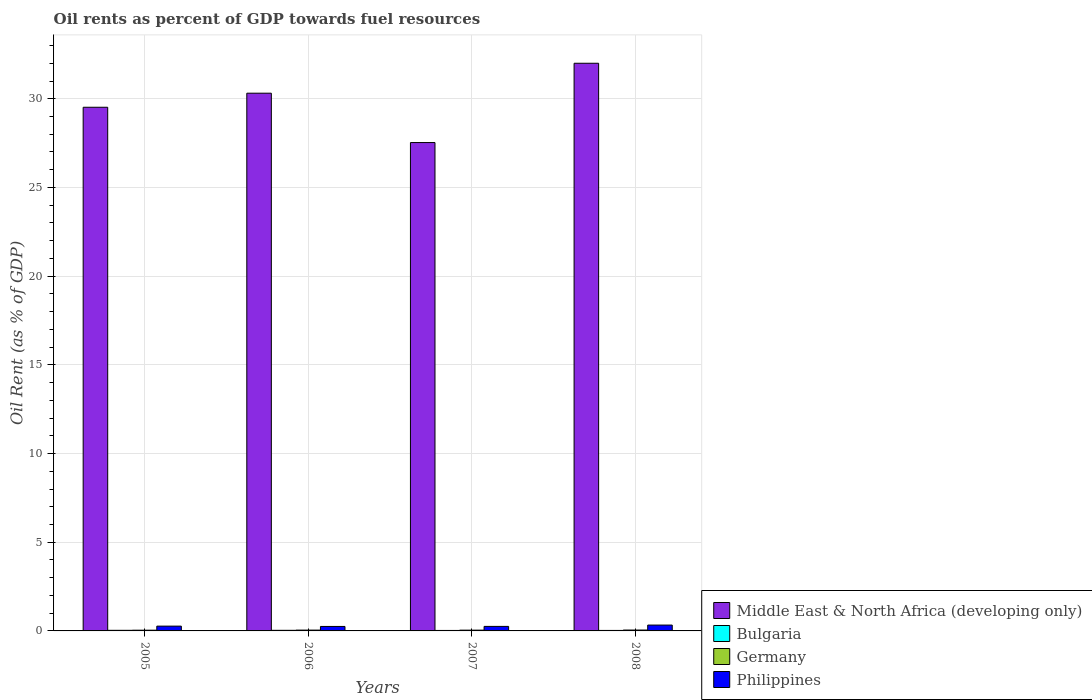How many different coloured bars are there?
Your response must be concise. 4. How many groups of bars are there?
Ensure brevity in your answer.  4. What is the oil rent in Middle East & North Africa (developing only) in 2007?
Make the answer very short. 27.53. Across all years, what is the maximum oil rent in Middle East & North Africa (developing only)?
Ensure brevity in your answer.  32. Across all years, what is the minimum oil rent in Philippines?
Give a very brief answer. 0.25. In which year was the oil rent in Middle East & North Africa (developing only) minimum?
Your answer should be compact. 2007. What is the total oil rent in Middle East & North Africa (developing only) in the graph?
Offer a terse response. 119.37. What is the difference between the oil rent in Germany in 2006 and that in 2008?
Offer a terse response. -0. What is the difference between the oil rent in Bulgaria in 2007 and the oil rent in Philippines in 2005?
Make the answer very short. -0.24. What is the average oil rent in Middle East & North Africa (developing only) per year?
Your answer should be compact. 29.84. In the year 2006, what is the difference between the oil rent in Middle East & North Africa (developing only) and oil rent in Philippines?
Your answer should be very brief. 30.06. In how many years, is the oil rent in Philippines greater than 4 %?
Offer a terse response. 0. What is the ratio of the oil rent in Philippines in 2006 to that in 2007?
Make the answer very short. 0.99. Is the difference between the oil rent in Middle East & North Africa (developing only) in 2007 and 2008 greater than the difference between the oil rent in Philippines in 2007 and 2008?
Your response must be concise. No. What is the difference between the highest and the second highest oil rent in Middle East & North Africa (developing only)?
Ensure brevity in your answer.  1.69. What is the difference between the highest and the lowest oil rent in Bulgaria?
Offer a terse response. 0.01. In how many years, is the oil rent in Philippines greater than the average oil rent in Philippines taken over all years?
Offer a very short reply. 1. Is it the case that in every year, the sum of the oil rent in Middle East & North Africa (developing only) and oil rent in Germany is greater than the sum of oil rent in Bulgaria and oil rent in Philippines?
Give a very brief answer. Yes. What does the 3rd bar from the left in 2007 represents?
Provide a succinct answer. Germany. What does the 4th bar from the right in 2006 represents?
Your answer should be very brief. Middle East & North Africa (developing only). Is it the case that in every year, the sum of the oil rent in Middle East & North Africa (developing only) and oil rent in Bulgaria is greater than the oil rent in Germany?
Offer a terse response. Yes. Are all the bars in the graph horizontal?
Provide a succinct answer. No. Does the graph contain grids?
Your response must be concise. Yes. What is the title of the graph?
Provide a succinct answer. Oil rents as percent of GDP towards fuel resources. What is the label or title of the Y-axis?
Ensure brevity in your answer.  Oil Rent (as % of GDP). What is the Oil Rent (as % of GDP) in Middle East & North Africa (developing only) in 2005?
Provide a short and direct response. 29.52. What is the Oil Rent (as % of GDP) of Bulgaria in 2005?
Offer a terse response. 0.03. What is the Oil Rent (as % of GDP) of Germany in 2005?
Offer a very short reply. 0.04. What is the Oil Rent (as % of GDP) in Philippines in 2005?
Your answer should be very brief. 0.27. What is the Oil Rent (as % of GDP) of Middle East & North Africa (developing only) in 2006?
Your answer should be very brief. 30.31. What is the Oil Rent (as % of GDP) of Bulgaria in 2006?
Give a very brief answer. 0.03. What is the Oil Rent (as % of GDP) of Germany in 2006?
Your answer should be compact. 0.05. What is the Oil Rent (as % of GDP) in Philippines in 2006?
Ensure brevity in your answer.  0.25. What is the Oil Rent (as % of GDP) of Middle East & North Africa (developing only) in 2007?
Ensure brevity in your answer.  27.53. What is the Oil Rent (as % of GDP) of Bulgaria in 2007?
Make the answer very short. 0.03. What is the Oil Rent (as % of GDP) of Germany in 2007?
Your answer should be compact. 0.04. What is the Oil Rent (as % of GDP) in Philippines in 2007?
Make the answer very short. 0.25. What is the Oil Rent (as % of GDP) in Middle East & North Africa (developing only) in 2008?
Provide a succinct answer. 32. What is the Oil Rent (as % of GDP) of Bulgaria in 2008?
Give a very brief answer. 0.03. What is the Oil Rent (as % of GDP) of Germany in 2008?
Offer a very short reply. 0.05. What is the Oil Rent (as % of GDP) of Philippines in 2008?
Ensure brevity in your answer.  0.33. Across all years, what is the maximum Oil Rent (as % of GDP) of Middle East & North Africa (developing only)?
Give a very brief answer. 32. Across all years, what is the maximum Oil Rent (as % of GDP) in Bulgaria?
Offer a very short reply. 0.03. Across all years, what is the maximum Oil Rent (as % of GDP) in Germany?
Your answer should be very brief. 0.05. Across all years, what is the maximum Oil Rent (as % of GDP) in Philippines?
Provide a succinct answer. 0.33. Across all years, what is the minimum Oil Rent (as % of GDP) in Middle East & North Africa (developing only)?
Offer a very short reply. 27.53. Across all years, what is the minimum Oil Rent (as % of GDP) in Bulgaria?
Ensure brevity in your answer.  0.03. Across all years, what is the minimum Oil Rent (as % of GDP) in Germany?
Offer a very short reply. 0.04. Across all years, what is the minimum Oil Rent (as % of GDP) of Philippines?
Provide a short and direct response. 0.25. What is the total Oil Rent (as % of GDP) in Middle East & North Africa (developing only) in the graph?
Ensure brevity in your answer.  119.37. What is the total Oil Rent (as % of GDP) in Bulgaria in the graph?
Your answer should be compact. 0.12. What is the total Oil Rent (as % of GDP) of Germany in the graph?
Provide a short and direct response. 0.18. What is the total Oil Rent (as % of GDP) of Philippines in the graph?
Give a very brief answer. 1.11. What is the difference between the Oil Rent (as % of GDP) in Middle East & North Africa (developing only) in 2005 and that in 2006?
Ensure brevity in your answer.  -0.79. What is the difference between the Oil Rent (as % of GDP) in Germany in 2005 and that in 2006?
Provide a short and direct response. -0.01. What is the difference between the Oil Rent (as % of GDP) of Philippines in 2005 and that in 2006?
Ensure brevity in your answer.  0.02. What is the difference between the Oil Rent (as % of GDP) in Middle East & North Africa (developing only) in 2005 and that in 2007?
Give a very brief answer. 1.99. What is the difference between the Oil Rent (as % of GDP) in Bulgaria in 2005 and that in 2007?
Offer a very short reply. 0.01. What is the difference between the Oil Rent (as % of GDP) in Germany in 2005 and that in 2007?
Give a very brief answer. -0. What is the difference between the Oil Rent (as % of GDP) of Philippines in 2005 and that in 2007?
Your answer should be compact. 0.02. What is the difference between the Oil Rent (as % of GDP) in Middle East & North Africa (developing only) in 2005 and that in 2008?
Provide a succinct answer. -2.48. What is the difference between the Oil Rent (as % of GDP) in Bulgaria in 2005 and that in 2008?
Provide a short and direct response. 0.01. What is the difference between the Oil Rent (as % of GDP) in Germany in 2005 and that in 2008?
Ensure brevity in your answer.  -0.01. What is the difference between the Oil Rent (as % of GDP) in Philippines in 2005 and that in 2008?
Your response must be concise. -0.06. What is the difference between the Oil Rent (as % of GDP) in Middle East & North Africa (developing only) in 2006 and that in 2007?
Provide a succinct answer. 2.78. What is the difference between the Oil Rent (as % of GDP) in Bulgaria in 2006 and that in 2007?
Keep it short and to the point. 0.01. What is the difference between the Oil Rent (as % of GDP) of Germany in 2006 and that in 2007?
Your answer should be very brief. 0. What is the difference between the Oil Rent (as % of GDP) in Philippines in 2006 and that in 2007?
Offer a very short reply. -0. What is the difference between the Oil Rent (as % of GDP) of Middle East & North Africa (developing only) in 2006 and that in 2008?
Offer a very short reply. -1.69. What is the difference between the Oil Rent (as % of GDP) of Bulgaria in 2006 and that in 2008?
Your answer should be very brief. 0.01. What is the difference between the Oil Rent (as % of GDP) in Germany in 2006 and that in 2008?
Offer a very short reply. -0. What is the difference between the Oil Rent (as % of GDP) of Philippines in 2006 and that in 2008?
Make the answer very short. -0.08. What is the difference between the Oil Rent (as % of GDP) of Middle East & North Africa (developing only) in 2007 and that in 2008?
Ensure brevity in your answer.  -4.47. What is the difference between the Oil Rent (as % of GDP) of Bulgaria in 2007 and that in 2008?
Provide a short and direct response. -0. What is the difference between the Oil Rent (as % of GDP) of Germany in 2007 and that in 2008?
Your answer should be very brief. -0.01. What is the difference between the Oil Rent (as % of GDP) in Philippines in 2007 and that in 2008?
Your response must be concise. -0.07. What is the difference between the Oil Rent (as % of GDP) of Middle East & North Africa (developing only) in 2005 and the Oil Rent (as % of GDP) of Bulgaria in 2006?
Ensure brevity in your answer.  29.49. What is the difference between the Oil Rent (as % of GDP) in Middle East & North Africa (developing only) in 2005 and the Oil Rent (as % of GDP) in Germany in 2006?
Ensure brevity in your answer.  29.47. What is the difference between the Oil Rent (as % of GDP) in Middle East & North Africa (developing only) in 2005 and the Oil Rent (as % of GDP) in Philippines in 2006?
Keep it short and to the point. 29.27. What is the difference between the Oil Rent (as % of GDP) in Bulgaria in 2005 and the Oil Rent (as % of GDP) in Germany in 2006?
Provide a succinct answer. -0.01. What is the difference between the Oil Rent (as % of GDP) of Bulgaria in 2005 and the Oil Rent (as % of GDP) of Philippines in 2006?
Your answer should be compact. -0.22. What is the difference between the Oil Rent (as % of GDP) of Germany in 2005 and the Oil Rent (as % of GDP) of Philippines in 2006?
Your response must be concise. -0.21. What is the difference between the Oil Rent (as % of GDP) in Middle East & North Africa (developing only) in 2005 and the Oil Rent (as % of GDP) in Bulgaria in 2007?
Your answer should be compact. 29.49. What is the difference between the Oil Rent (as % of GDP) in Middle East & North Africa (developing only) in 2005 and the Oil Rent (as % of GDP) in Germany in 2007?
Offer a terse response. 29.48. What is the difference between the Oil Rent (as % of GDP) in Middle East & North Africa (developing only) in 2005 and the Oil Rent (as % of GDP) in Philippines in 2007?
Give a very brief answer. 29.27. What is the difference between the Oil Rent (as % of GDP) of Bulgaria in 2005 and the Oil Rent (as % of GDP) of Germany in 2007?
Keep it short and to the point. -0.01. What is the difference between the Oil Rent (as % of GDP) in Bulgaria in 2005 and the Oil Rent (as % of GDP) in Philippines in 2007?
Your response must be concise. -0.22. What is the difference between the Oil Rent (as % of GDP) in Germany in 2005 and the Oil Rent (as % of GDP) in Philippines in 2007?
Provide a short and direct response. -0.21. What is the difference between the Oil Rent (as % of GDP) in Middle East & North Africa (developing only) in 2005 and the Oil Rent (as % of GDP) in Bulgaria in 2008?
Your answer should be compact. 29.49. What is the difference between the Oil Rent (as % of GDP) of Middle East & North Africa (developing only) in 2005 and the Oil Rent (as % of GDP) of Germany in 2008?
Give a very brief answer. 29.47. What is the difference between the Oil Rent (as % of GDP) of Middle East & North Africa (developing only) in 2005 and the Oil Rent (as % of GDP) of Philippines in 2008?
Provide a succinct answer. 29.19. What is the difference between the Oil Rent (as % of GDP) of Bulgaria in 2005 and the Oil Rent (as % of GDP) of Germany in 2008?
Give a very brief answer. -0.02. What is the difference between the Oil Rent (as % of GDP) in Bulgaria in 2005 and the Oil Rent (as % of GDP) in Philippines in 2008?
Your answer should be very brief. -0.3. What is the difference between the Oil Rent (as % of GDP) of Germany in 2005 and the Oil Rent (as % of GDP) of Philippines in 2008?
Offer a terse response. -0.29. What is the difference between the Oil Rent (as % of GDP) of Middle East & North Africa (developing only) in 2006 and the Oil Rent (as % of GDP) of Bulgaria in 2007?
Give a very brief answer. 30.29. What is the difference between the Oil Rent (as % of GDP) in Middle East & North Africa (developing only) in 2006 and the Oil Rent (as % of GDP) in Germany in 2007?
Give a very brief answer. 30.27. What is the difference between the Oil Rent (as % of GDP) of Middle East & North Africa (developing only) in 2006 and the Oil Rent (as % of GDP) of Philippines in 2007?
Ensure brevity in your answer.  30.06. What is the difference between the Oil Rent (as % of GDP) in Bulgaria in 2006 and the Oil Rent (as % of GDP) in Germany in 2007?
Ensure brevity in your answer.  -0.01. What is the difference between the Oil Rent (as % of GDP) in Bulgaria in 2006 and the Oil Rent (as % of GDP) in Philippines in 2007?
Offer a very short reply. -0.22. What is the difference between the Oil Rent (as % of GDP) of Germany in 2006 and the Oil Rent (as % of GDP) of Philippines in 2007?
Make the answer very short. -0.21. What is the difference between the Oil Rent (as % of GDP) in Middle East & North Africa (developing only) in 2006 and the Oil Rent (as % of GDP) in Bulgaria in 2008?
Your answer should be very brief. 30.29. What is the difference between the Oil Rent (as % of GDP) of Middle East & North Africa (developing only) in 2006 and the Oil Rent (as % of GDP) of Germany in 2008?
Make the answer very short. 30.26. What is the difference between the Oil Rent (as % of GDP) of Middle East & North Africa (developing only) in 2006 and the Oil Rent (as % of GDP) of Philippines in 2008?
Offer a terse response. 29.98. What is the difference between the Oil Rent (as % of GDP) in Bulgaria in 2006 and the Oil Rent (as % of GDP) in Germany in 2008?
Ensure brevity in your answer.  -0.02. What is the difference between the Oil Rent (as % of GDP) in Bulgaria in 2006 and the Oil Rent (as % of GDP) in Philippines in 2008?
Ensure brevity in your answer.  -0.3. What is the difference between the Oil Rent (as % of GDP) in Germany in 2006 and the Oil Rent (as % of GDP) in Philippines in 2008?
Offer a very short reply. -0.28. What is the difference between the Oil Rent (as % of GDP) in Middle East & North Africa (developing only) in 2007 and the Oil Rent (as % of GDP) in Bulgaria in 2008?
Offer a very short reply. 27.5. What is the difference between the Oil Rent (as % of GDP) of Middle East & North Africa (developing only) in 2007 and the Oil Rent (as % of GDP) of Germany in 2008?
Your response must be concise. 27.48. What is the difference between the Oil Rent (as % of GDP) of Middle East & North Africa (developing only) in 2007 and the Oil Rent (as % of GDP) of Philippines in 2008?
Make the answer very short. 27.2. What is the difference between the Oil Rent (as % of GDP) of Bulgaria in 2007 and the Oil Rent (as % of GDP) of Germany in 2008?
Make the answer very short. -0.02. What is the difference between the Oil Rent (as % of GDP) in Bulgaria in 2007 and the Oil Rent (as % of GDP) in Philippines in 2008?
Your answer should be compact. -0.3. What is the difference between the Oil Rent (as % of GDP) in Germany in 2007 and the Oil Rent (as % of GDP) in Philippines in 2008?
Offer a terse response. -0.29. What is the average Oil Rent (as % of GDP) of Middle East & North Africa (developing only) per year?
Give a very brief answer. 29.84. What is the average Oil Rent (as % of GDP) of Bulgaria per year?
Provide a succinct answer. 0.03. What is the average Oil Rent (as % of GDP) in Germany per year?
Your response must be concise. 0.05. What is the average Oil Rent (as % of GDP) in Philippines per year?
Your response must be concise. 0.28. In the year 2005, what is the difference between the Oil Rent (as % of GDP) of Middle East & North Africa (developing only) and Oil Rent (as % of GDP) of Bulgaria?
Your response must be concise. 29.49. In the year 2005, what is the difference between the Oil Rent (as % of GDP) of Middle East & North Africa (developing only) and Oil Rent (as % of GDP) of Germany?
Your answer should be very brief. 29.48. In the year 2005, what is the difference between the Oil Rent (as % of GDP) of Middle East & North Africa (developing only) and Oil Rent (as % of GDP) of Philippines?
Give a very brief answer. 29.25. In the year 2005, what is the difference between the Oil Rent (as % of GDP) of Bulgaria and Oil Rent (as % of GDP) of Germany?
Your response must be concise. -0.01. In the year 2005, what is the difference between the Oil Rent (as % of GDP) of Bulgaria and Oil Rent (as % of GDP) of Philippines?
Provide a succinct answer. -0.24. In the year 2005, what is the difference between the Oil Rent (as % of GDP) of Germany and Oil Rent (as % of GDP) of Philippines?
Offer a terse response. -0.23. In the year 2006, what is the difference between the Oil Rent (as % of GDP) of Middle East & North Africa (developing only) and Oil Rent (as % of GDP) of Bulgaria?
Offer a terse response. 30.28. In the year 2006, what is the difference between the Oil Rent (as % of GDP) of Middle East & North Africa (developing only) and Oil Rent (as % of GDP) of Germany?
Your answer should be compact. 30.27. In the year 2006, what is the difference between the Oil Rent (as % of GDP) of Middle East & North Africa (developing only) and Oil Rent (as % of GDP) of Philippines?
Provide a short and direct response. 30.06. In the year 2006, what is the difference between the Oil Rent (as % of GDP) in Bulgaria and Oil Rent (as % of GDP) in Germany?
Give a very brief answer. -0.01. In the year 2006, what is the difference between the Oil Rent (as % of GDP) in Bulgaria and Oil Rent (as % of GDP) in Philippines?
Offer a terse response. -0.22. In the year 2006, what is the difference between the Oil Rent (as % of GDP) of Germany and Oil Rent (as % of GDP) of Philippines?
Your answer should be very brief. -0.21. In the year 2007, what is the difference between the Oil Rent (as % of GDP) in Middle East & North Africa (developing only) and Oil Rent (as % of GDP) in Bulgaria?
Make the answer very short. 27.5. In the year 2007, what is the difference between the Oil Rent (as % of GDP) of Middle East & North Africa (developing only) and Oil Rent (as % of GDP) of Germany?
Give a very brief answer. 27.49. In the year 2007, what is the difference between the Oil Rent (as % of GDP) in Middle East & North Africa (developing only) and Oil Rent (as % of GDP) in Philippines?
Offer a terse response. 27.28. In the year 2007, what is the difference between the Oil Rent (as % of GDP) in Bulgaria and Oil Rent (as % of GDP) in Germany?
Make the answer very short. -0.02. In the year 2007, what is the difference between the Oil Rent (as % of GDP) in Bulgaria and Oil Rent (as % of GDP) in Philippines?
Offer a very short reply. -0.23. In the year 2007, what is the difference between the Oil Rent (as % of GDP) of Germany and Oil Rent (as % of GDP) of Philippines?
Provide a succinct answer. -0.21. In the year 2008, what is the difference between the Oil Rent (as % of GDP) in Middle East & North Africa (developing only) and Oil Rent (as % of GDP) in Bulgaria?
Your answer should be compact. 31.97. In the year 2008, what is the difference between the Oil Rent (as % of GDP) of Middle East & North Africa (developing only) and Oil Rent (as % of GDP) of Germany?
Provide a succinct answer. 31.95. In the year 2008, what is the difference between the Oil Rent (as % of GDP) in Middle East & North Africa (developing only) and Oil Rent (as % of GDP) in Philippines?
Your response must be concise. 31.67. In the year 2008, what is the difference between the Oil Rent (as % of GDP) of Bulgaria and Oil Rent (as % of GDP) of Germany?
Your answer should be very brief. -0.02. In the year 2008, what is the difference between the Oil Rent (as % of GDP) in Bulgaria and Oil Rent (as % of GDP) in Philippines?
Ensure brevity in your answer.  -0.3. In the year 2008, what is the difference between the Oil Rent (as % of GDP) in Germany and Oil Rent (as % of GDP) in Philippines?
Provide a short and direct response. -0.28. What is the ratio of the Oil Rent (as % of GDP) of Middle East & North Africa (developing only) in 2005 to that in 2006?
Keep it short and to the point. 0.97. What is the ratio of the Oil Rent (as % of GDP) of Bulgaria in 2005 to that in 2006?
Give a very brief answer. 1.01. What is the ratio of the Oil Rent (as % of GDP) of Germany in 2005 to that in 2006?
Offer a very short reply. 0.89. What is the ratio of the Oil Rent (as % of GDP) in Philippines in 2005 to that in 2006?
Your answer should be very brief. 1.07. What is the ratio of the Oil Rent (as % of GDP) of Middle East & North Africa (developing only) in 2005 to that in 2007?
Make the answer very short. 1.07. What is the ratio of the Oil Rent (as % of GDP) in Bulgaria in 2005 to that in 2007?
Make the answer very short. 1.29. What is the ratio of the Oil Rent (as % of GDP) of Germany in 2005 to that in 2007?
Give a very brief answer. 0.93. What is the ratio of the Oil Rent (as % of GDP) of Philippines in 2005 to that in 2007?
Offer a terse response. 1.06. What is the ratio of the Oil Rent (as % of GDP) of Middle East & North Africa (developing only) in 2005 to that in 2008?
Offer a terse response. 0.92. What is the ratio of the Oil Rent (as % of GDP) in Bulgaria in 2005 to that in 2008?
Your answer should be compact. 1.24. What is the ratio of the Oil Rent (as % of GDP) of Germany in 2005 to that in 2008?
Provide a short and direct response. 0.82. What is the ratio of the Oil Rent (as % of GDP) in Philippines in 2005 to that in 2008?
Your answer should be very brief. 0.82. What is the ratio of the Oil Rent (as % of GDP) in Middle East & North Africa (developing only) in 2006 to that in 2007?
Your answer should be compact. 1.1. What is the ratio of the Oil Rent (as % of GDP) of Bulgaria in 2006 to that in 2007?
Your answer should be very brief. 1.27. What is the ratio of the Oil Rent (as % of GDP) in Germany in 2006 to that in 2007?
Make the answer very short. 1.05. What is the ratio of the Oil Rent (as % of GDP) of Middle East & North Africa (developing only) in 2006 to that in 2008?
Offer a very short reply. 0.95. What is the ratio of the Oil Rent (as % of GDP) in Bulgaria in 2006 to that in 2008?
Ensure brevity in your answer.  1.22. What is the ratio of the Oil Rent (as % of GDP) in Germany in 2006 to that in 2008?
Offer a terse response. 0.92. What is the ratio of the Oil Rent (as % of GDP) in Philippines in 2006 to that in 2008?
Give a very brief answer. 0.77. What is the ratio of the Oil Rent (as % of GDP) of Middle East & North Africa (developing only) in 2007 to that in 2008?
Offer a terse response. 0.86. What is the ratio of the Oil Rent (as % of GDP) in Bulgaria in 2007 to that in 2008?
Your response must be concise. 0.96. What is the ratio of the Oil Rent (as % of GDP) of Germany in 2007 to that in 2008?
Provide a succinct answer. 0.88. What is the ratio of the Oil Rent (as % of GDP) in Philippines in 2007 to that in 2008?
Your answer should be compact. 0.77. What is the difference between the highest and the second highest Oil Rent (as % of GDP) of Middle East & North Africa (developing only)?
Your answer should be very brief. 1.69. What is the difference between the highest and the second highest Oil Rent (as % of GDP) in Germany?
Your answer should be very brief. 0. What is the difference between the highest and the second highest Oil Rent (as % of GDP) of Philippines?
Offer a very short reply. 0.06. What is the difference between the highest and the lowest Oil Rent (as % of GDP) of Middle East & North Africa (developing only)?
Make the answer very short. 4.47. What is the difference between the highest and the lowest Oil Rent (as % of GDP) of Bulgaria?
Offer a very short reply. 0.01. What is the difference between the highest and the lowest Oil Rent (as % of GDP) in Germany?
Offer a very short reply. 0.01. What is the difference between the highest and the lowest Oil Rent (as % of GDP) in Philippines?
Give a very brief answer. 0.08. 